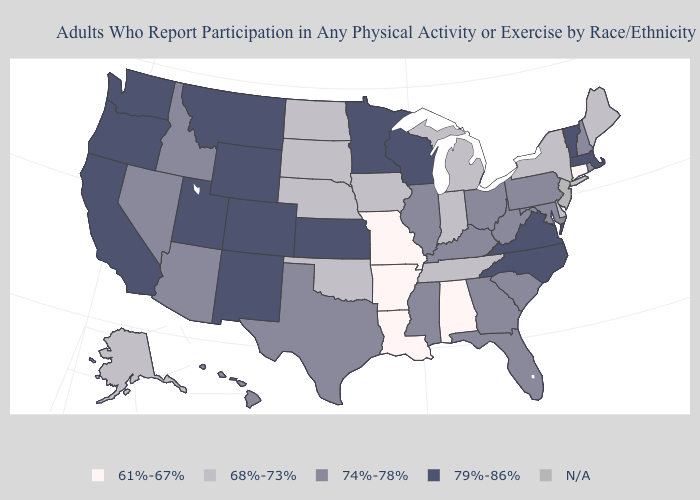Among the states that border West Virginia , which have the lowest value?
Keep it brief. Kentucky, Maryland, Ohio, Pennsylvania. What is the lowest value in the West?
Concise answer only. 68%-73%. Among the states that border Missouri , does Kansas have the highest value?
Short answer required. Yes. Does Ohio have the highest value in the USA?
Write a very short answer. No. What is the value of Colorado?
Keep it brief. 79%-86%. Does the first symbol in the legend represent the smallest category?
Be succinct. Yes. Name the states that have a value in the range 74%-78%?
Answer briefly. Arizona, Florida, Georgia, Hawaii, Idaho, Illinois, Kentucky, Maryland, Mississippi, Nevada, New Hampshire, Ohio, Pennsylvania, Rhode Island, South Carolina, Texas, West Virginia. Name the states that have a value in the range 61%-67%?
Quick response, please. Alabama, Arkansas, Connecticut, Louisiana, Missouri. Which states have the highest value in the USA?
Write a very short answer. California, Colorado, Kansas, Massachusetts, Minnesota, Montana, New Mexico, North Carolina, Oregon, Utah, Vermont, Virginia, Washington, Wisconsin, Wyoming. Among the states that border Alabama , which have the highest value?
Answer briefly. Florida, Georgia, Mississippi. What is the value of Missouri?
Quick response, please. 61%-67%. What is the value of Wyoming?
Write a very short answer. 79%-86%. What is the value of Georgia?
Concise answer only. 74%-78%. Name the states that have a value in the range 61%-67%?
Short answer required. Alabama, Arkansas, Connecticut, Louisiana, Missouri. 